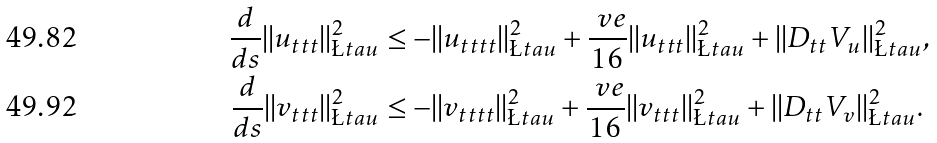<formula> <loc_0><loc_0><loc_500><loc_500>\frac { d } { d s } | | u _ { t t t } | | ^ { 2 } _ { \L t a u } & \leq - | | u _ { t t t t } | | ^ { 2 } _ { \L t a u } + \frac { \ v e } { 1 6 } | | u _ { t t t } | | ^ { 2 } _ { \L t a u } + | | D _ { t t } V _ { u } | | ^ { 2 } _ { \L t a u } , \\ \frac { d } { d s } | | v _ { t t t } | | ^ { 2 } _ { \L t a u } & \leq - | | v _ { t t t t } | | ^ { 2 } _ { \L t a u } + \frac { \ v e } { 1 6 } | | v _ { t t t } | | ^ { 2 } _ { \L t a u } + | | D _ { t t } V _ { v } | | ^ { 2 } _ { \L t a u } .</formula> 